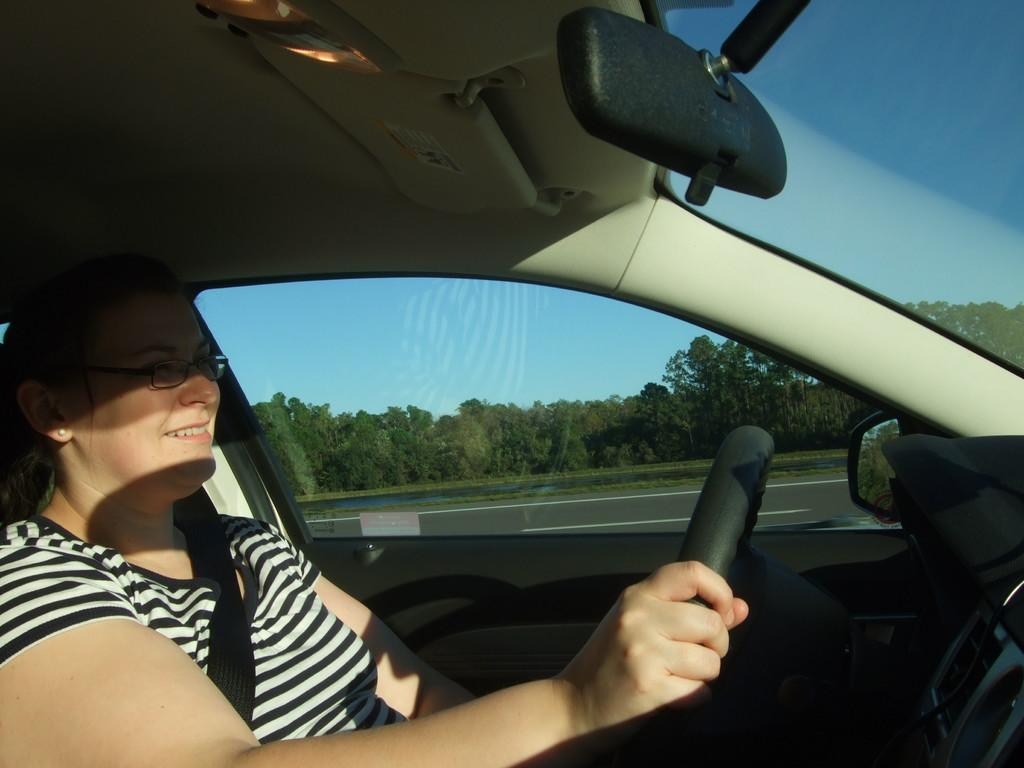Who is the main subject in the image? There is a lady in the image. What is the lady doing in the image? The lady is sitting in a car and holding the steering wheel. What can be seen through the car window? Trees and the sky are visible through the car window. How does the lady appear in the image? The lady has a smile on her face. What type of farming equipment is the lady using in the image? There is no farming equipment present in the image; the lady is sitting in a car. What type of representative is the lady in the image? There is no indication in the image that the lady is a representative of any organization or group. 